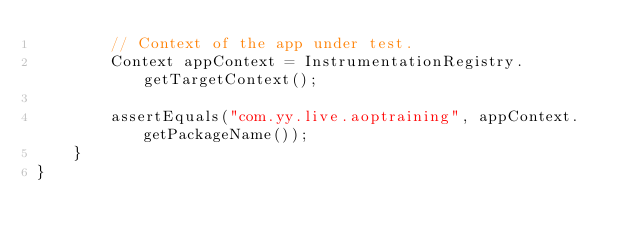<code> <loc_0><loc_0><loc_500><loc_500><_Java_>        // Context of the app under test.
        Context appContext = InstrumentationRegistry.getTargetContext();

        assertEquals("com.yy.live.aoptraining", appContext.getPackageName());
    }
}
</code> 